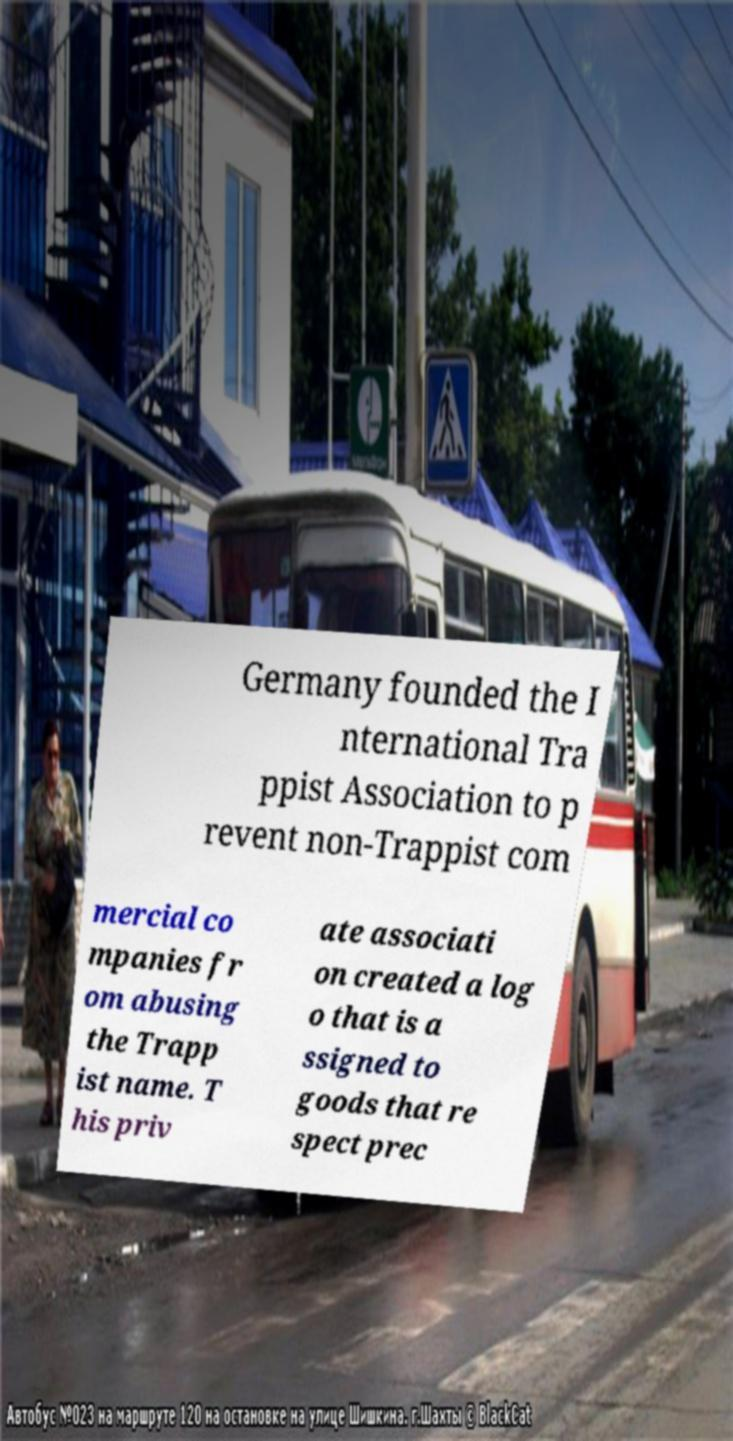Can you read and provide the text displayed in the image?This photo seems to have some interesting text. Can you extract and type it out for me? Germany founded the I nternational Tra ppist Association to p revent non-Trappist com mercial co mpanies fr om abusing the Trapp ist name. T his priv ate associati on created a log o that is a ssigned to goods that re spect prec 